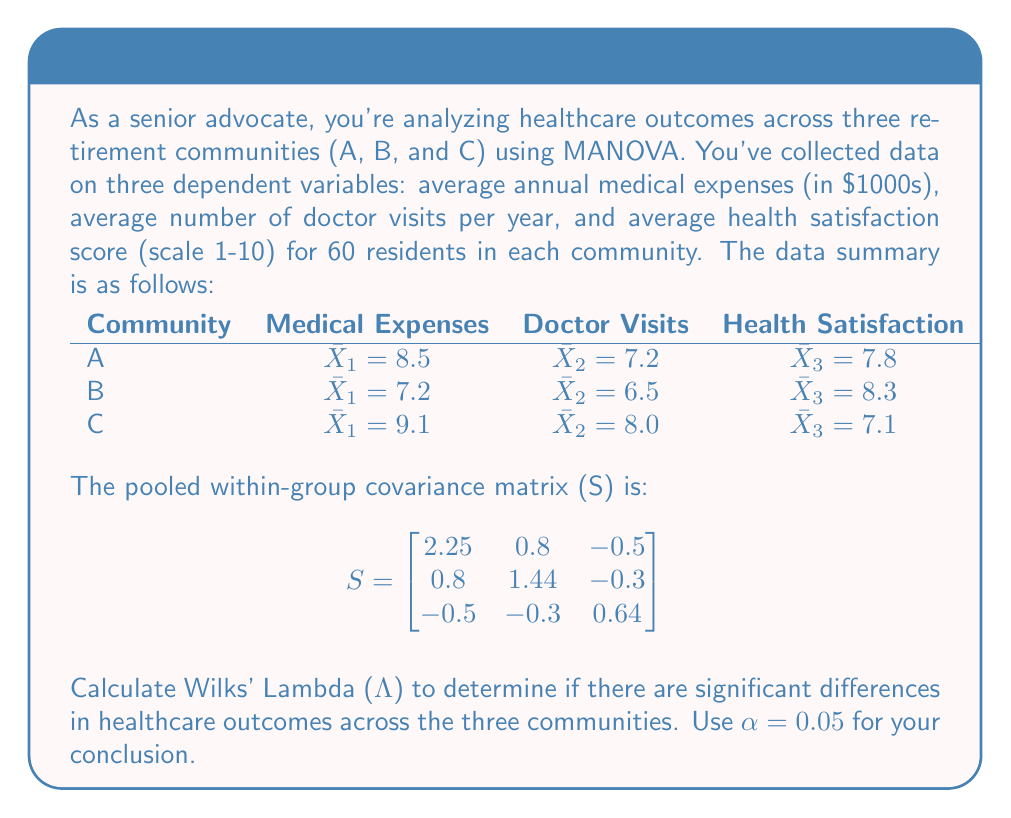Provide a solution to this math problem. To calculate Wilks' Lambda (Λ) and determine if there are significant differences in healthcare outcomes across the three communities, we'll follow these steps:

1) First, calculate the total sum of squares and cross-products matrix (T):
   
   $$T = \sum_{i=1}^{g} n_i (\bar{X}_i - \bar{X})(\bar{X}_i - \bar{X})'$$
   
   where g is the number of groups (3 in this case), n_i is the sample size per group (60), and $\bar{X}$ is the grand mean.

2) Calculate the grand mean:
   
   $\bar{X}_1 = (8.5 + 7.2 + 9.1) / 3 = 8.27$
   $\bar{X}_2 = (7.2 + 6.5 + 8.0) / 3 = 7.23$
   $\bar{X}_3 = (7.8 + 8.3 + 7.1) / 3 = 7.73$

3) Calculate T:
   
   $$T = 60 \begin{bmatrix}
   (8.5-8.27)^2+(7.2-8.27)^2+(9.1-8.27)^2 & ... & ... \\
   ... & (7.2-7.23)^2+(6.5-7.23)^2+(8.0-7.23)^2 & ... \\
   ... & ... & (7.8-7.73)^2+(8.3-7.73)^2+(7.1-7.73)^2
   \end{bmatrix}$$

   $$T = \begin{bmatrix}
   110.52 & 39.6 & -24.6 \\
   39.6 & 85.68 & -17.4 \\
   -24.6 & -17.4 & 38.64
   \end{bmatrix}$$

4) Calculate Wilks' Lambda:
   
   $$Λ = \frac{|S|}{|S+T|}$$

   where |S| is the determinant of S and |S+T| is the determinant of S+T.

5) Calculate |S|:
   
   $$|S| = 2.25(1.44*0.64 - (-0.3)^2) - 0.8(0.8*0.64 - (-0.5)(-0.3)) + (-0.5)(0.8(-0.3) - 1.44(-0.5)) = 1.9764$$

6) Calculate S+T:
   
   $$S+T = \begin{bmatrix}
   112.77 & 40.4 & -25.1 \\
   40.4 & 87.12 & -17.7 \\
   -25.1 & -17.7 & 39.28
   \end{bmatrix}$$

7) Calculate |S+T|:
   
   $$|S+T| = 308,928.5684$$

8) Calculate Wilks' Lambda:
   
   $$Λ = \frac{1.9764}{308,928.5684} = 0.0000064$$

9) To test for significance, we can use the F-approximation:
   
   $$F = \frac{1-Λ^{1/t}}{\Lambda^{1/t}} \cdot \frac{df_2}{df_1}$$
   
   where $t = \sqrt{\frac{p^2m^2-4}{p^2+m^2-5}}$, p is the number of dependent variables (3), m is the degrees of freedom for hypothesis (g-1 = 2), df1 = p(g-1) = 6, and df2 = wt - 0.5(p - g + 1) where w = n - g = 180 - 3 = 177.

10) Calculate t:
    
    $$t = \sqrt{\frac{3^2 * 2^2 - 4}{3^2 + 2^2 - 5}} = 1.7321$$

11) Calculate F:
    
    $$F = \frac{1-0.0000064^{1/1.7321}}{0.0000064^{1/1.7321}} \cdot \frac{525.5}{6} = 13,679.8767$$

12) Compare F to the critical value. With df1 = 6 and df2 = 525.5, the critical F-value at α = 0.05 is approximately 2.12.

Since our calculated F (13,679.8767) is much larger than the critical F (2.12), we reject the null hypothesis.
Answer: Wilks' Λ = 0.0000064, F = 13,679.8767. Reject null hypothesis; significant differences exist in healthcare outcomes across communities. 